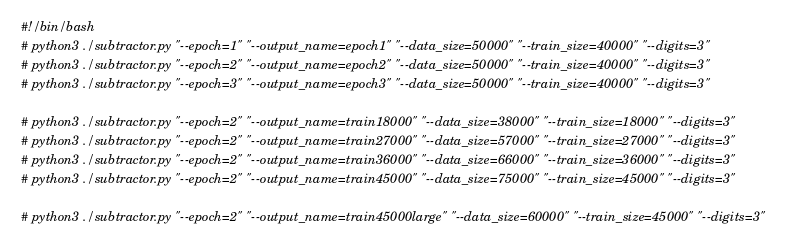<code> <loc_0><loc_0><loc_500><loc_500><_Bash_>#!/bin/bash
# python3 ./subtractor.py "--epoch=1" "--output_name=epoch1" "--data_size=50000" "--train_size=40000" "--digits=3"
# python3 ./subtractor.py "--epoch=2" "--output_name=epoch2" "--data_size=50000" "--train_size=40000" "--digits=3"
# python3 ./subtractor.py "--epoch=3" "--output_name=epoch3" "--data_size=50000" "--train_size=40000" "--digits=3"

# python3 ./subtractor.py "--epoch=2" "--output_name=train18000" "--data_size=38000" "--train_size=18000" "--digits=3"
# python3 ./subtractor.py "--epoch=2" "--output_name=train27000" "--data_size=57000" "--train_size=27000" "--digits=3"
# python3 ./subtractor.py "--epoch=2" "--output_name=train36000" "--data_size=66000" "--train_size=36000" "--digits=3"
# python3 ./subtractor.py "--epoch=2" "--output_name=train45000" "--data_size=75000" "--train_size=45000" "--digits=3"

# python3 ./subtractor.py "--epoch=2" "--output_name=train45000large" "--data_size=60000" "--train_size=45000" "--digits=3"
</code> 